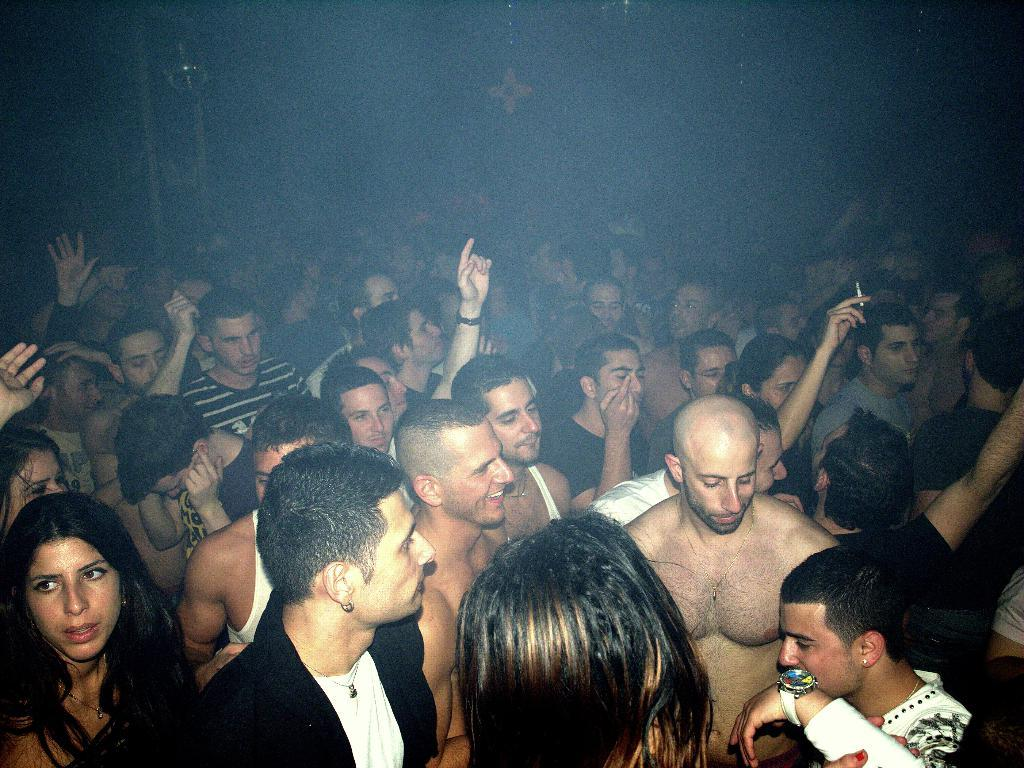What is the main subject of the image? The main subject of the image is a crowd. What can be observed about the background of the image? The background of the image is dark. Based on the darkness of the background, what can be inferred about the time the image was taken? The image was likely taken during the night. Where might the image have been taken? The image was likely taken on a road. What type of beef can be seen hanging from the streetlights in the image? There is no beef present in the image; it features a crowd on a road with a dark background. How many cars are visible in the image? There are no cars visible in the image; it only shows a crowd on a road. 